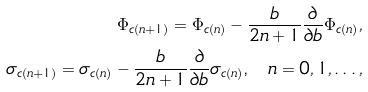Convert formula to latex. <formula><loc_0><loc_0><loc_500><loc_500>\Phi _ { c ( n + 1 ) } = \Phi _ { c ( n ) } - \frac { b } { 2 n + 1 } \frac { \partial } { \partial b } \Phi _ { c ( n ) } , \\ \sigma _ { c ( n + 1 ) } = \sigma _ { c ( n ) } - \frac { b } { 2 n + 1 } \frac { \partial } { \partial b } \sigma _ { c ( n ) } \text {,} \quad n = 0 , 1 , \dots ,</formula> 